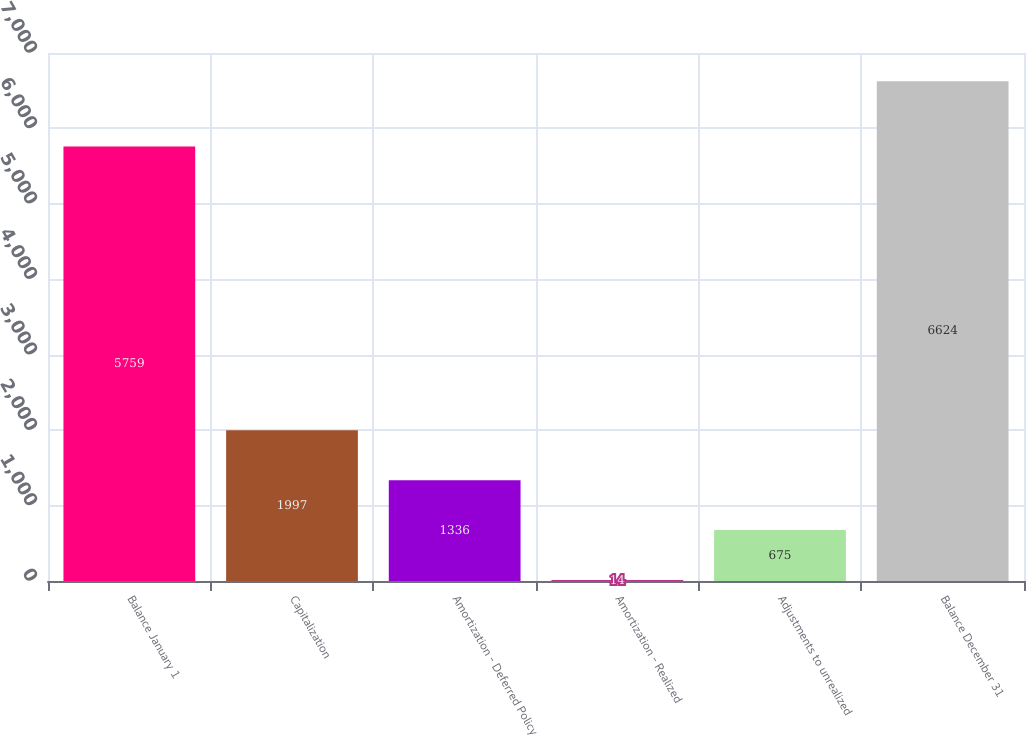<chart> <loc_0><loc_0><loc_500><loc_500><bar_chart><fcel>Balance January 1<fcel>Capitalization<fcel>Amortization - Deferred Policy<fcel>Amortization - Realized<fcel>Adjustments to unrealized<fcel>Balance December 31<nl><fcel>5759<fcel>1997<fcel>1336<fcel>14<fcel>675<fcel>6624<nl></chart> 